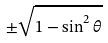Convert formula to latex. <formula><loc_0><loc_0><loc_500><loc_500>\pm \sqrt { 1 - \sin ^ { 2 } \theta }</formula> 